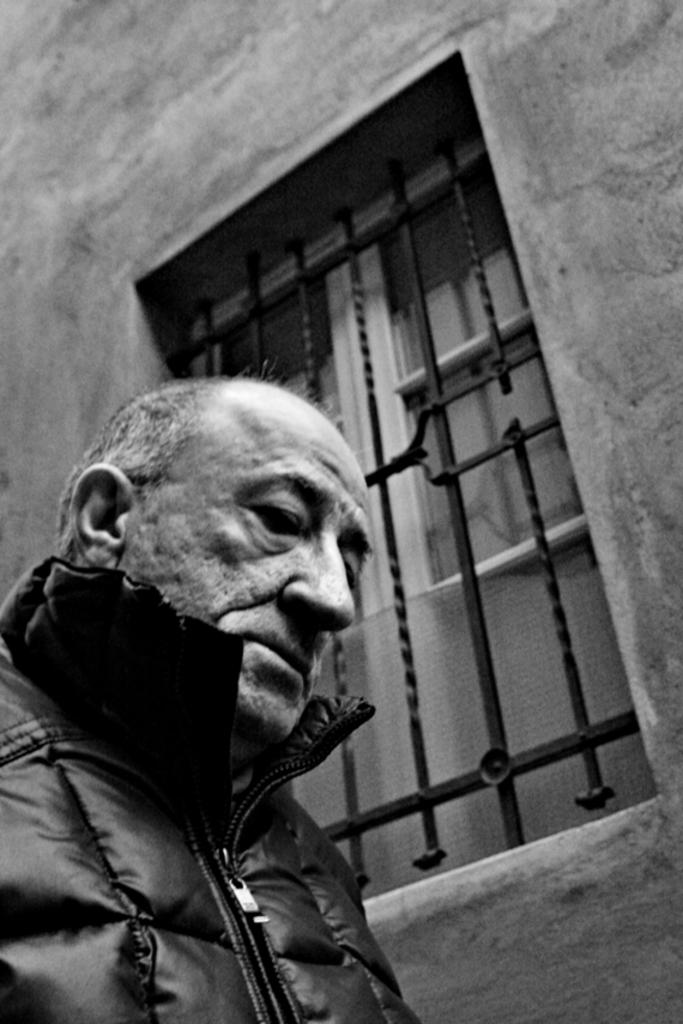Who is on the left side of the image? There is an old man on the left side of the image. What can be seen in the background of the image? There is a wall with a window in the image. What type of grills are present for the window? There are grills for the window grills in the image. What type of doors are present for the window? There are wooden doors for the window. What is the weight of the paper on the old man's desk in the image? There is no paper or desk present in the image, so it is not possible to determine the weight of any paper. 